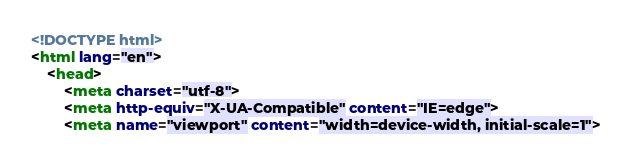Convert code to text. <code><loc_0><loc_0><loc_500><loc_500><_HTML_><!DOCTYPE html>
<html lang="en">
	<head>
		<meta charset="utf-8">
		<meta http-equiv="X-UA-Compatible" content="IE=edge">
		<meta name="viewport" content="width=device-width, initial-scale=1"></code> 